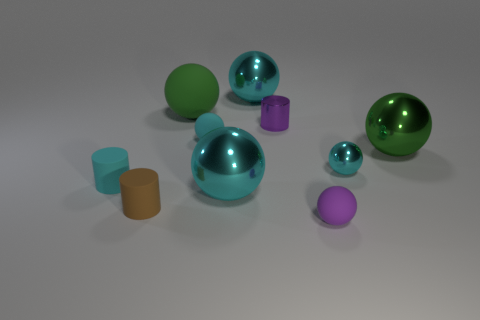What is the material of the ball that is the same color as the shiny cylinder?
Your answer should be compact. Rubber. There is a small cyan sphere in front of the tiny cyan thing behind the green metallic object; are there any cyan spheres behind it?
Offer a terse response. Yes. Are there fewer green balls in front of the small purple ball than brown matte cylinders left of the cyan cylinder?
Your response must be concise. No. There is a large sphere that is made of the same material as the brown object; what is its color?
Provide a succinct answer. Green. There is a rubber sphere that is to the right of the small cylinder on the right side of the large green rubber object; what color is it?
Provide a short and direct response. Purple. Are there any small cylinders that have the same color as the small metallic sphere?
Provide a succinct answer. Yes. There is a purple metal object that is the same size as the brown matte thing; what shape is it?
Provide a succinct answer. Cylinder. What number of small rubber cylinders are on the left side of the green sphere behind the large green metal thing?
Make the answer very short. 2. Does the metal cylinder have the same color as the tiny metallic ball?
Keep it short and to the point. No. What number of other objects are the same material as the tiny brown object?
Your answer should be compact. 4. 